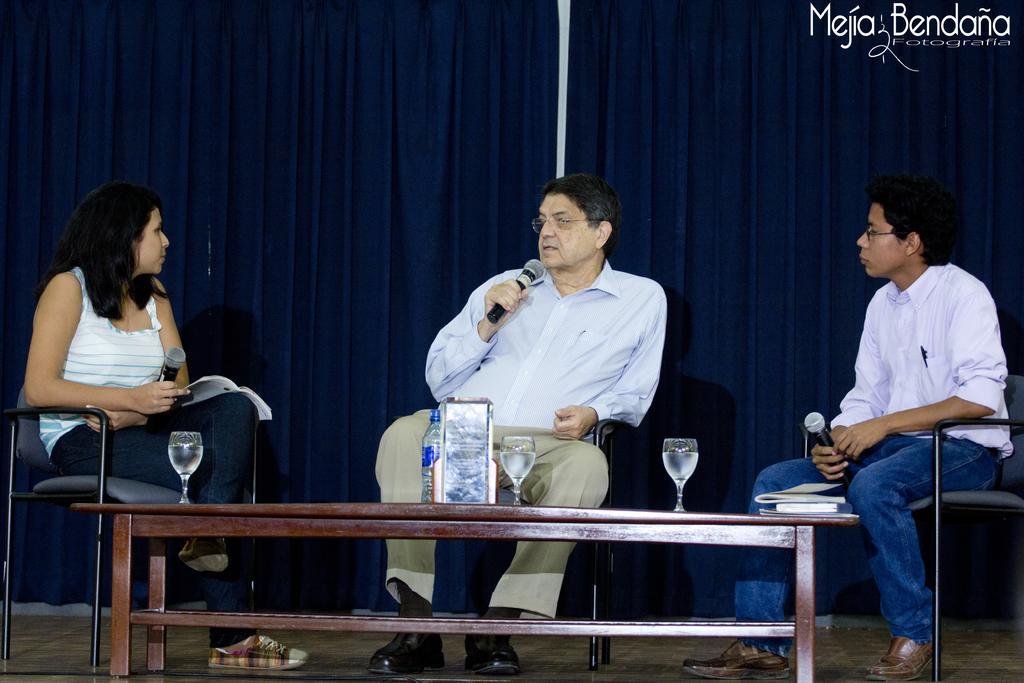Could you give a brief overview of what you see in this image? As we can see in the image there is a curtain and three people sitting on chairs and there is a table. On table there is a bottle and glasses. 